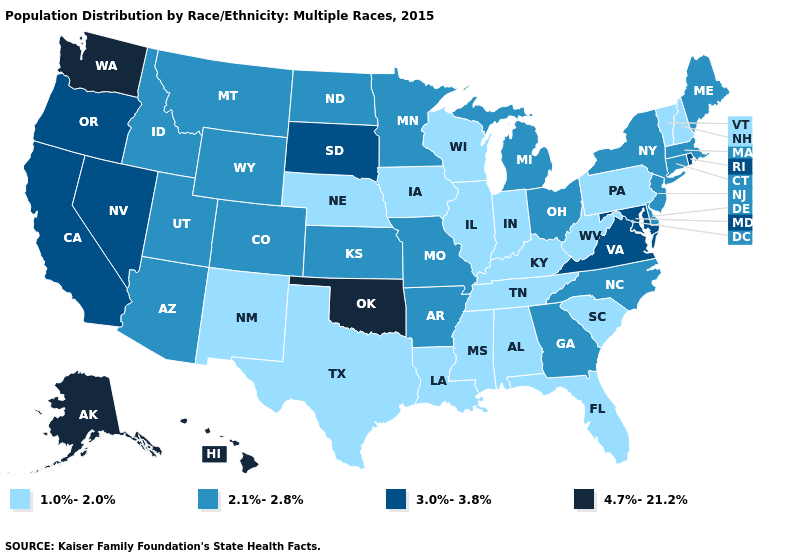What is the value of Maryland?
Keep it brief. 3.0%-3.8%. Does Wisconsin have the lowest value in the USA?
Concise answer only. Yes. Name the states that have a value in the range 3.0%-3.8%?
Write a very short answer. California, Maryland, Nevada, Oregon, Rhode Island, South Dakota, Virginia. What is the value of Tennessee?
Short answer required. 1.0%-2.0%. Which states hav the highest value in the Northeast?
Concise answer only. Rhode Island. What is the value of New Hampshire?
Concise answer only. 1.0%-2.0%. What is the highest value in states that border Maine?
Short answer required. 1.0%-2.0%. What is the value of Oregon?
Give a very brief answer. 3.0%-3.8%. What is the lowest value in the MidWest?
Keep it brief. 1.0%-2.0%. Does the first symbol in the legend represent the smallest category?
Be succinct. Yes. What is the value of Indiana?
Short answer required. 1.0%-2.0%. What is the value of Mississippi?
Be succinct. 1.0%-2.0%. Does Oregon have the lowest value in the USA?
Short answer required. No. What is the highest value in states that border Tennessee?
Short answer required. 3.0%-3.8%. What is the value of Colorado?
Write a very short answer. 2.1%-2.8%. 